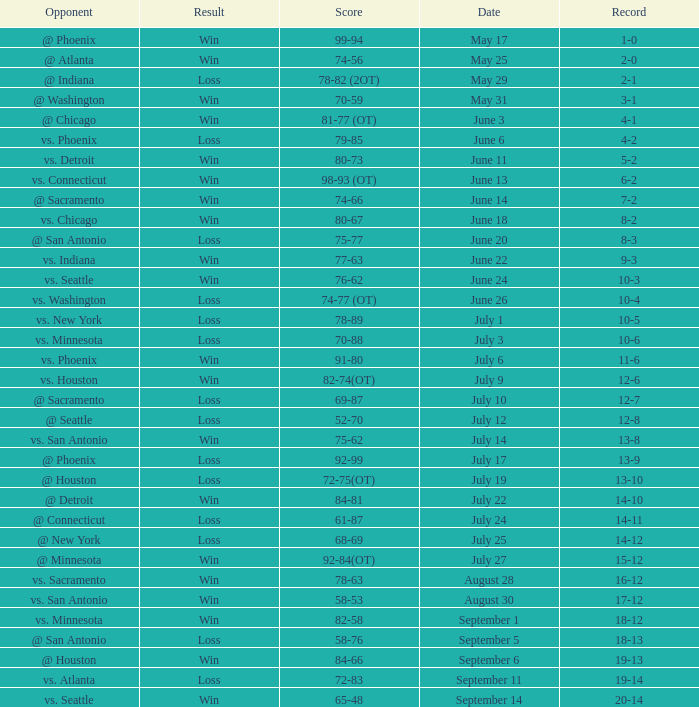What is the Score of the game @ San Antonio on June 20? 75-77. 